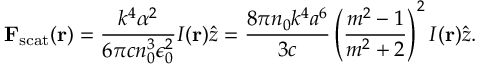<formula> <loc_0><loc_0><loc_500><loc_500>F _ { s c a t } ( r ) = { \frac { k ^ { 4 } \alpha ^ { 2 } } { 6 \pi c n _ { 0 } ^ { 3 } \epsilon _ { 0 } ^ { 2 } } } I ( r ) { \hat { z } } = { \frac { 8 \pi n _ { 0 } k ^ { 4 } a ^ { 6 } } { 3 c } } \left ( { \frac { m ^ { 2 } - 1 } { m ^ { 2 } + 2 } } \right ) ^ { 2 } I ( r ) { \hat { z } } .</formula> 